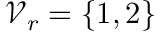<formula> <loc_0><loc_0><loc_500><loc_500>\mathcal { V } _ { r } = \{ 1 , 2 \}</formula> 